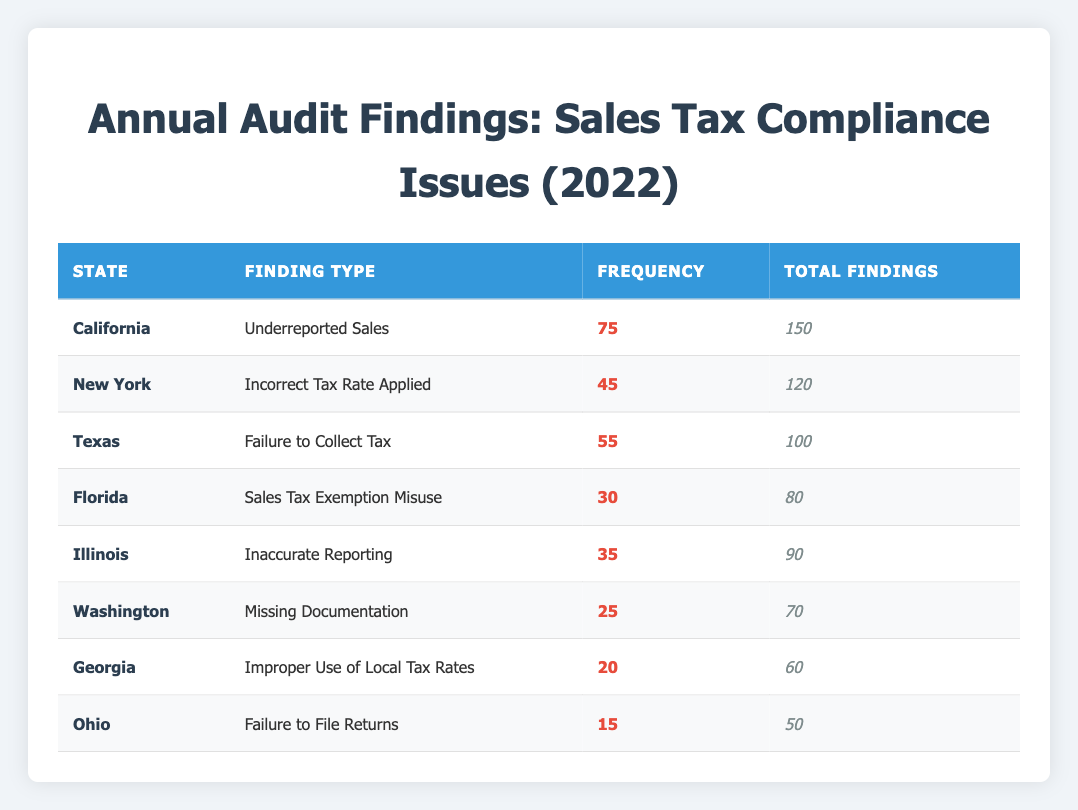What is the total number of findings for the state of California? According to the table, the total findings for California are listed in the "Total Findings" column. By referring to the row for California, the value is 150.
Answer: 150 How many findings related to "Failure to Collect Tax" were reported in Texas? In the table, we locate Texas and observe the "Finding Type" column, where it specifies "Failure to Collect Tax." The corresponding "Frequency" for this finding is noted as 55.
Answer: 55 Which state had the highest frequency of sales tax compliance issue findings? To determine the highest frequency, we compare the "Frequency" values across all states. California has the highest frequency at 75 for "Underreported Sales." Thus, California is the answer.
Answer: California What is the combined frequency of findings for Florida and Ohio? We look at the "Frequency" values for Florida (30) and Ohio (15) in the table. Adding these two values gives us 30 + 15 = 45, which is the combined frequency.
Answer: 45 Is there any finding type that has a frequency greater than 50? We examine the "Frequency" column to see which finding types exceed 50. California with 75 and Texas with 55 both qualify, so the answer is Yes.
Answer: Yes How many total findings were reported across all states in the table? By summing the "Total Findings" from each state: 150 (California) + 120 (New York) + 100 (Texas) + 80 (Florida) + 90 (Illinois) + 70 (Washington) + 60 (Georgia) + 50 (Ohio) = 820. Therefore, the total findings amount to 820.
Answer: 820 What is the frequency of findings marked as "Sales Tax Exemption Misuse" in Florida? Within the table, we look for Florida and check the "Finding Type" which shows "Sales Tax Exemption Misuse." The associated frequency indicated is 30.
Answer: 30 Which state or states reported findings for "Incorrect Tax Rate Applied"? In the table, we identify the specific finding type "Incorrect Tax Rate Applied" and observe that it is listed under New York. Hence, the answer pertains exclusively to New York.
Answer: New York What is the average frequency of findings across all reported states? We first sum the frequency values: 75 + 45 + 55 + 30 + 35 + 25 + 20 + 15 = 300. There are 8 states. To find the average, we divide the total frequency by the number of states: 300 / 8 = 37.5. Therefore, the average frequency is 37.5.
Answer: 37.5 